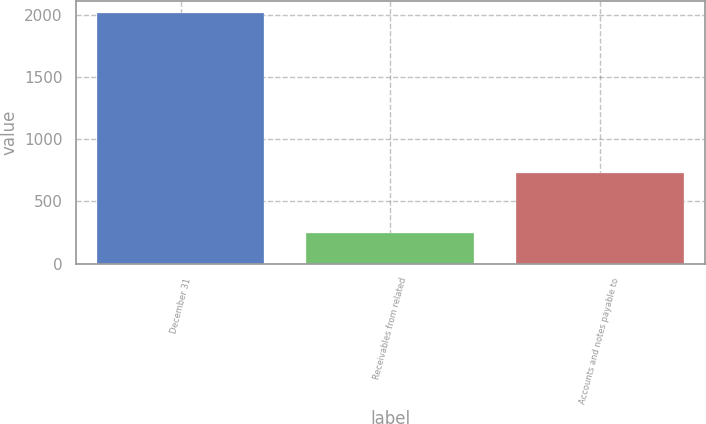Convert chart to OTSL. <chart><loc_0><loc_0><loc_500><loc_500><bar_chart><fcel>December 31<fcel>Receivables from related<fcel>Accounts and notes payable to<nl><fcel>2017<fcel>250<fcel>727<nl></chart> 